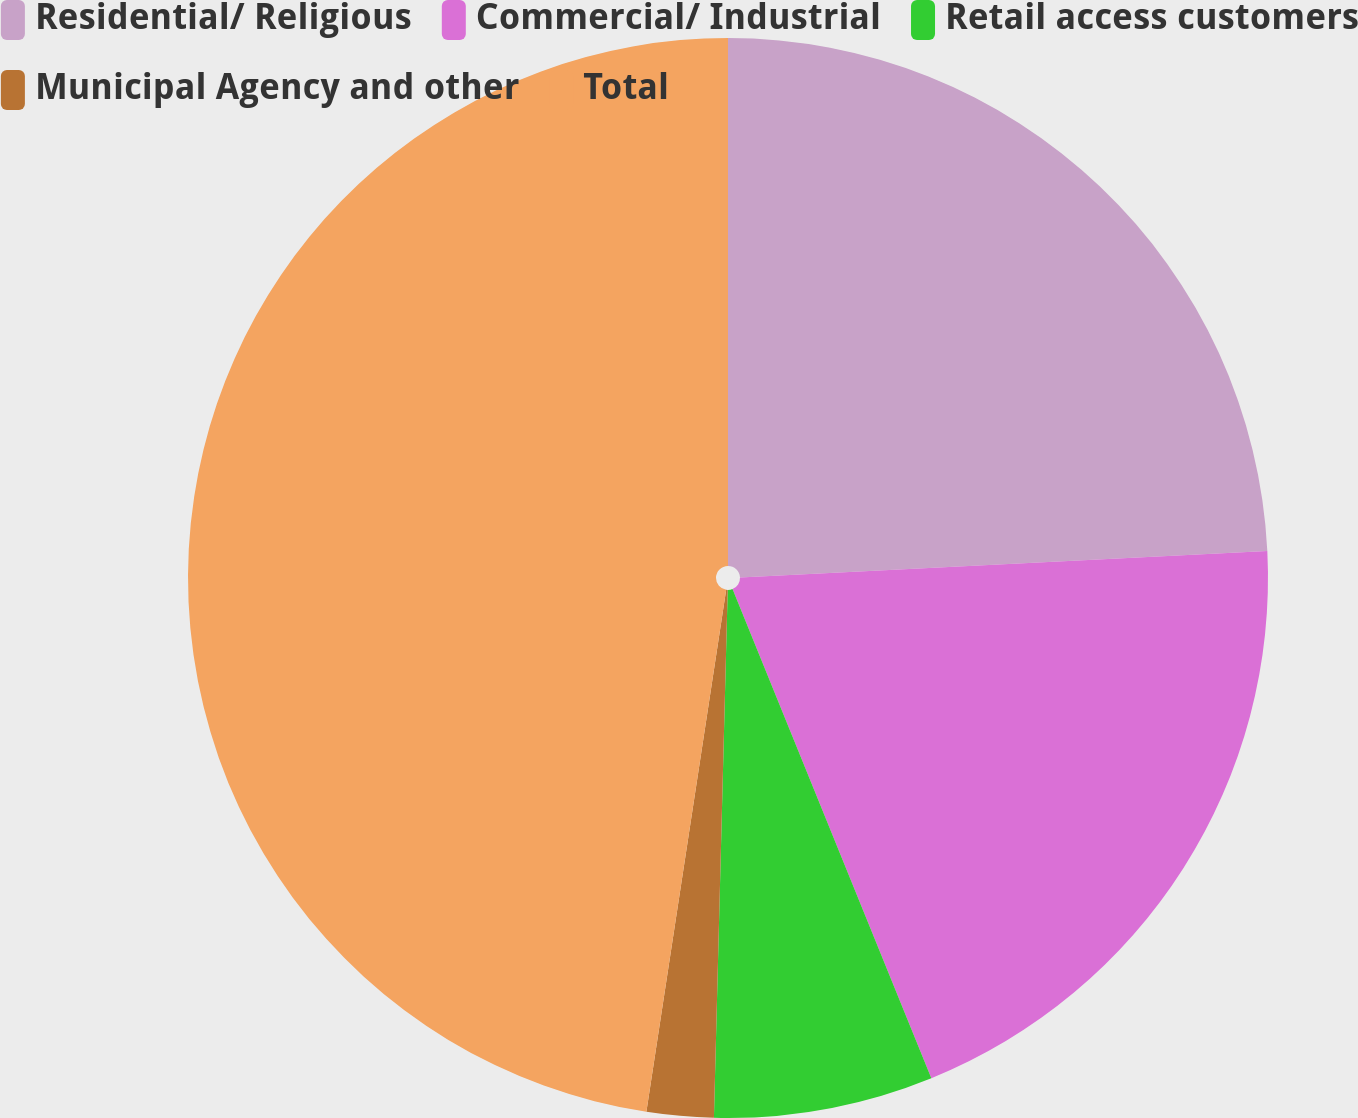<chart> <loc_0><loc_0><loc_500><loc_500><pie_chart><fcel>Residential/ Religious<fcel>Commercial/ Industrial<fcel>Retail access customers<fcel>Municipal Agency and other<fcel>Total<nl><fcel>24.21%<fcel>19.65%<fcel>6.56%<fcel>2.0%<fcel>47.59%<nl></chart> 